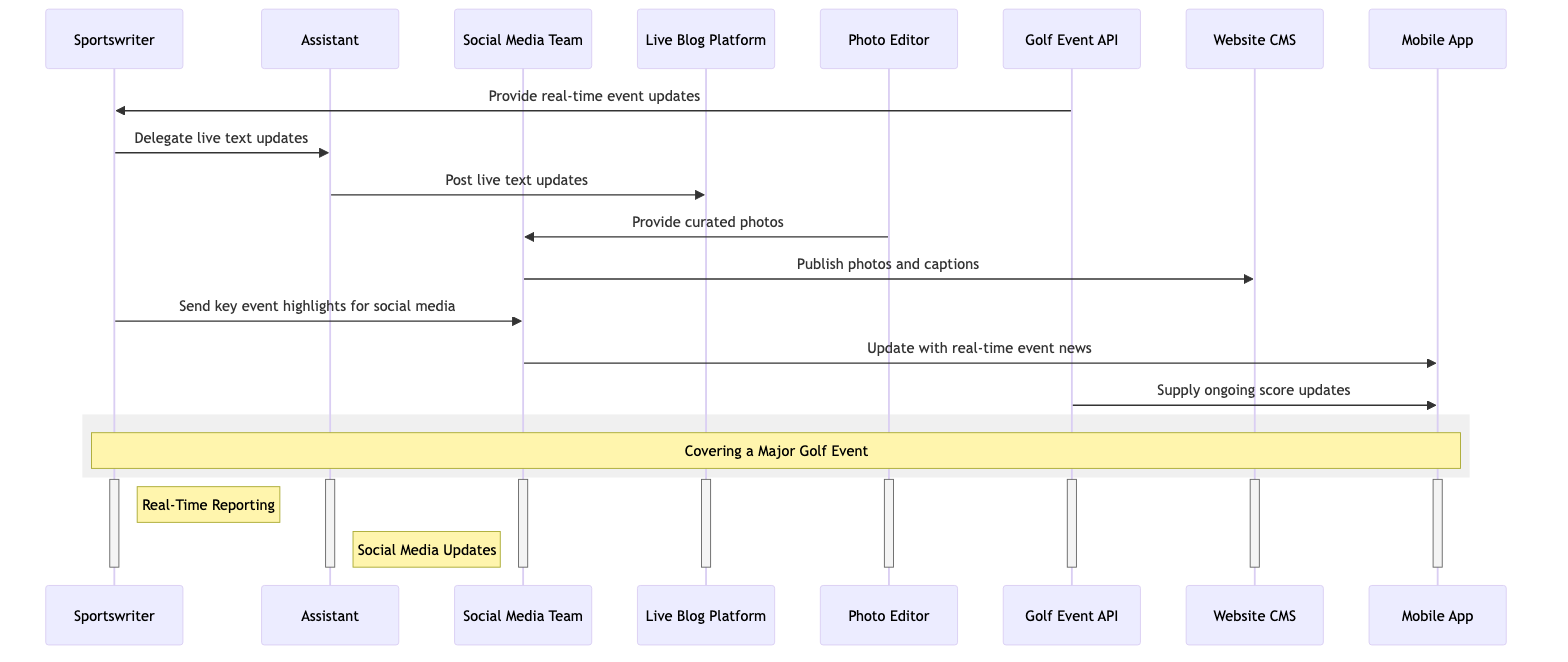What is the first interaction in the sequence? The first interaction shown in the diagram is from the Golf Event API to the Sportswriter, where it provides real-time event updates.
Answer: Provide real-time event updates How many actors are involved in the diagram? The diagram lists eight different actors involved in the process of covering a major golf event.
Answer: Eight Who posts the live text updates? According to the sequence, the Assistant is responsible for posting live text updates to the Live Blog Platform.
Answer: Assistant What does the Sportswriter send to the Social Media Team? The Sportswriter sends key event highlights to the Social Media Team for social media updates.
Answer: Key event highlights What is the role of the Photo Editor in the sequence? The Photo Editor is tasked with providing curated photos to the Social Media Team for publication.
Answer: Provide curated photos Which two actors are activated during the Social Media Updates process? The active actors during the Social Media Updates process are the Social Media Team and the Mobile App, as they interact directly for updates.
Answer: Social Media Team, Mobile App Describe the relationship between the Golf Event API and the Mobile App. The Golf Event API supplies ongoing score updates to the Mobile App, showing a direct flow of information regarding event scores.
Answer: Supply ongoing score updates How many interactions are initiated by the Sportswriter? The Sportswriter initiates three interactions: one with the Assistant, one with the Social Media Team, and another in the context of real-time event reporting.
Answer: Three 